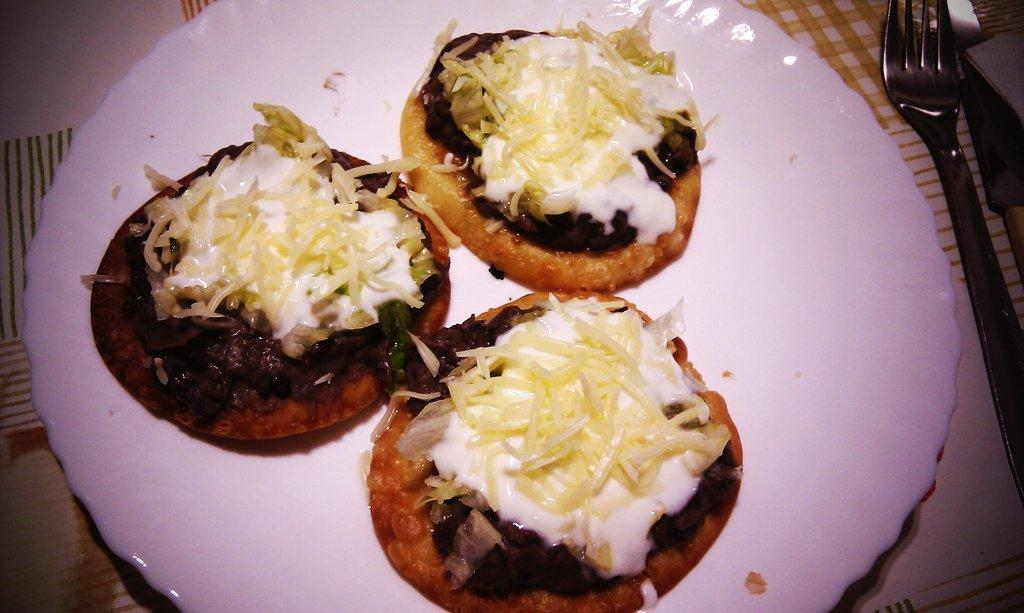What is covering the table in the image? The table is covered with a tablecloth. What can be seen on top of the tablecloth? There are objects and food items on the table. What type of design can be seen on the camera in the image? There is no camera present in the image; it only features objects and food items on a table covered with a tablecloth. 